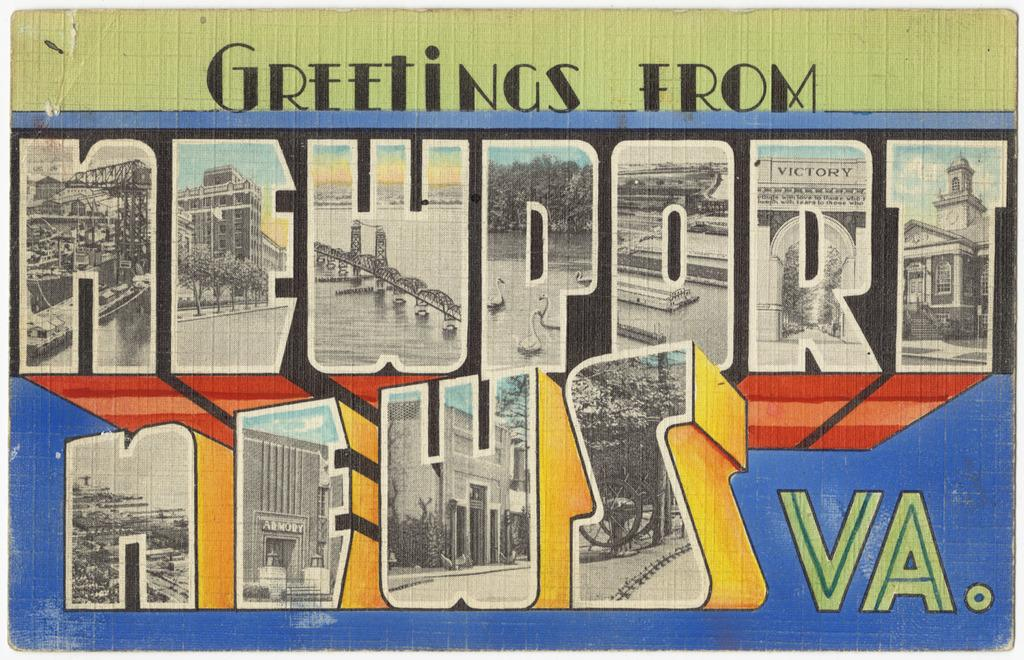<image>
Render a clear and concise summary of the photo. The postcard is for vistors of Newport in VA. 